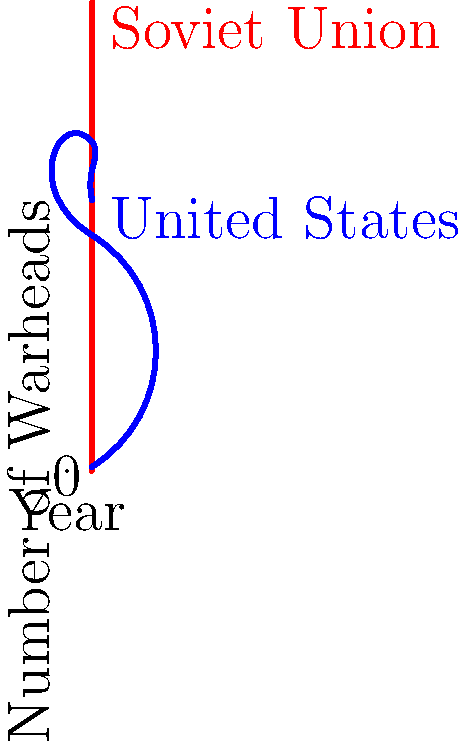Based on the graph showing the nuclear arsenals of the Soviet Union and the United States during the Cold War, in which decade did the Soviet Union surpass the United States in terms of the number of nuclear warheads? To determine when the Soviet Union surpassed the United States in nuclear warheads, we need to analyze the graph decade by decade:

1. 1950s: The US clearly had more warheads than the USSR.
2. 1960s: The US still maintained a significant lead.
3. 1970s: The lines for both countries are very close, indicating similar numbers.
4. 1980s: The Soviet line crosses above the US line, showing that the USSR surpassed the US in warhead count.
5. 1990s: The Soviet/Russian arsenal continued to grow while the US arsenal declined.

The critical point occurs in the 1980s when the red line (Soviet Union) crosses above the blue line (United States). This intersection represents the moment when the Soviet nuclear arsenal became larger than the American arsenal.

Therefore, the Soviet Union surpassed the United States in terms of nuclear warheads during the 1980s.
Answer: 1980s 